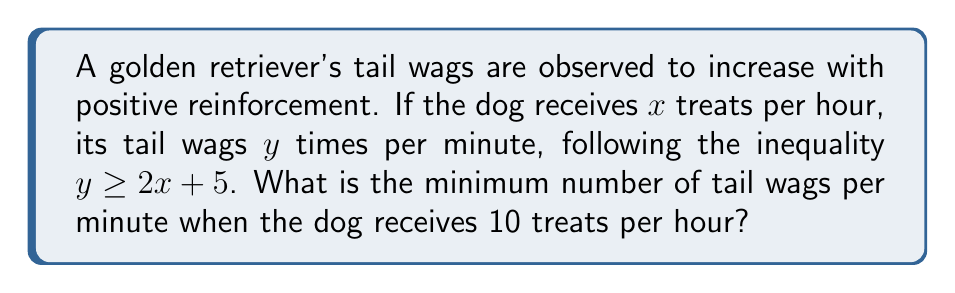Could you help me with this problem? Let's approach this step-by-step:

1) The relationship between treats $(x)$ and tail wags $(y)$ is given by the inequality:

   $y \geq 2x + 5$

2) We're asked about the scenario where the dog receives 10 treats per hour, so let's substitute $x = 10$:

   $y \geq 2(10) + 5$

3) Simplify:

   $y \geq 20 + 5$
   $y \geq 25$

4) This inequality tells us that when the dog receives 10 treats per hour, it will wag its tail at least 25 times per minute.

5) Since we're asked for the minimum number of tail wags, we're looking for the smallest value of $y$ that satisfies this inequality.

6) The minimum value that satisfies $y \geq 25$ is exactly 25.

Therefore, the minimum number of tail wags per minute when the dog receives 10 treats per hour is 25.
Answer: 25 